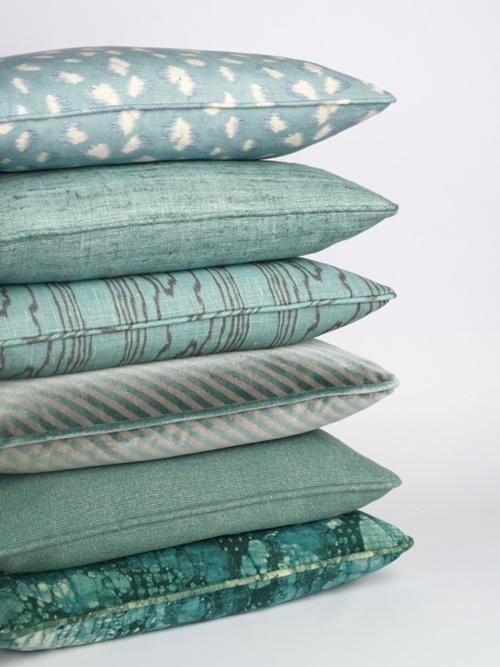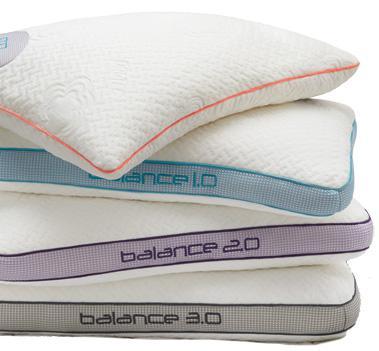The first image is the image on the left, the second image is the image on the right. For the images shown, is this caption "A pillow stack includes a pinkish-violet pillow the second from the bottom." true? Answer yes or no. No. The first image is the image on the left, the second image is the image on the right. Evaluate the accuracy of this statement regarding the images: "There are at most 7 pillows in the pair of images.". Is it true? Answer yes or no. No. 